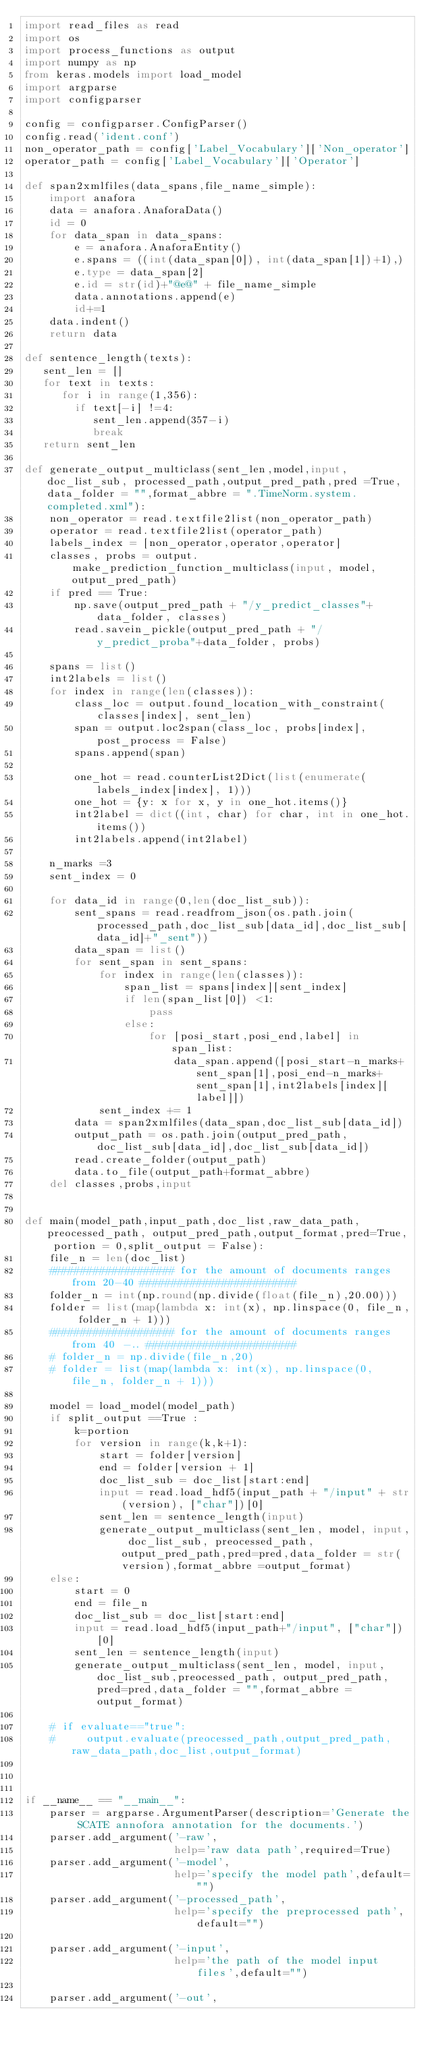<code> <loc_0><loc_0><loc_500><loc_500><_Python_>import read_files as read
import os
import process_functions as output
import numpy as np
from keras.models import load_model
import argparse
import configparser

config = configparser.ConfigParser()
config.read('ident.conf')
non_operator_path = config['Label_Vocabulary']['Non_operator']
operator_path = config['Label_Vocabulary']['Operator']

def span2xmlfiles(data_spans,file_name_simple):
    import anafora
    data = anafora.AnaforaData()
    id = 0
    for data_span in data_spans:
        e = anafora.AnaforaEntity()
        e.spans = ((int(data_span[0]), int(data_span[1])+1),)
        e.type = data_span[2]
        e.id = str(id)+"@e@" + file_name_simple
        data.annotations.append(e)
        id+=1
    data.indent()
    return data

def sentence_length(texts):
   sent_len = []
   for text in texts:
      for i in range(1,356):
        if text[-i] !=4:
           sent_len.append(357-i)
           break
   return sent_len

def generate_output_multiclass(sent_len,model,input,doc_list_sub, processed_path,output_pred_path,pred =True,data_folder = "",format_abbre = ".TimeNorm.system.completed.xml"):
    non_operator = read.textfile2list(non_operator_path)
    operator = read.textfile2list(operator_path)
    labels_index = [non_operator,operator,operator]
    classes, probs = output.make_prediction_function_multiclass(input, model, output_pred_path)
    if pred == True:
        np.save(output_pred_path + "/y_predict_classes"+data_folder, classes)
        read.savein_pickle(output_pred_path + "/y_predict_proba"+data_folder, probs)

    spans = list()
    int2labels = list()
    for index in range(len(classes)):
        class_loc = output.found_location_with_constraint(classes[index], sent_len)
        span = output.loc2span(class_loc, probs[index],post_process = False)
        spans.append(span)

        one_hot = read.counterList2Dict(list(enumerate(labels_index[index], 1)))
        one_hot = {y: x for x, y in one_hot.items()}
        int2label = dict((int, char) for char, int in one_hot.items())
        int2labels.append(int2label)

    n_marks =3
    sent_index = 0

    for data_id in range(0,len(doc_list_sub)):
        sent_spans = read.readfrom_json(os.path.join(processed_path,doc_list_sub[data_id],doc_list_sub[data_id]+"_sent"))
        data_span = list()
        for sent_span in sent_spans:
            for index in range(len(classes)):
                span_list = spans[index][sent_index]
                if len(span_list[0]) <1:
                    pass
                else:
                    for [posi_start,posi_end,label] in span_list:
                        data_span.append([posi_start-n_marks+sent_span[1],posi_end-n_marks+ sent_span[1],int2labels[index][label]])
            sent_index += 1
        data = span2xmlfiles(data_span,doc_list_sub[data_id])
        output_path = os.path.join(output_pred_path,doc_list_sub[data_id],doc_list_sub[data_id])
        read.create_folder(output_path)
        data.to_file(output_path+format_abbre)
    del classes,probs,input


def main(model_path,input_path,doc_list,raw_data_path, preocessed_path, output_pred_path,output_format,pred=True, portion = 0,split_output = False):
    file_n = len(doc_list)
    #################### for the amount of documents ranges from 20-40 #########################
    folder_n = int(np.round(np.divide(float(file_n),20.00)))
    folder = list(map(lambda x: int(x), np.linspace(0, file_n, folder_n + 1)))
    #################### for the amount of documents ranges from 40 -.. ########################
    # folder_n = np.divide(file_n,20)
    # folder = list(map(lambda x: int(x), np.linspace(0, file_n, folder_n + 1)))

    model = load_model(model_path)
    if split_output ==True :
        k=portion
        for version in range(k,k+1):
            start = folder[version]
            end = folder[version + 1]
            doc_list_sub = doc_list[start:end]
            input = read.load_hdf5(input_path + "/input" + str(version), ["char"])[0]
            sent_len = sentence_length(input)
            generate_output_multiclass(sent_len, model, input, doc_list_sub, preocessed_path,output_pred_path,pred=pred,data_folder = str(version),format_abbre =output_format)
    else:
        start = 0
        end = file_n
        doc_list_sub = doc_list[start:end]
        input = read.load_hdf5(input_path+"/input", ["char"])[0]
        sent_len = sentence_length(input)
        generate_output_multiclass(sent_len, model, input,doc_list_sub,preocessed_path, output_pred_path,pred=pred,data_folder = "",format_abbre =output_format)

    # if evaluate=="true":
    #     output.evaluate(preocessed_path,output_pred_path,raw_data_path,doc_list,output_format)



if __name__ == "__main__":
    parser = argparse.ArgumentParser(description='Generate the SCATE annofora annotation for the documents.')
    parser.add_argument('-raw',
                        help='raw data path',required=True)
    parser.add_argument('-model',
                        help='specify the model path',default="")
    parser.add_argument('-processed_path',
                        help='specify the preprocessed path',default="")

    parser.add_argument('-input',
                        help='the path of the model input files',default="")

    parser.add_argument('-out',</code> 